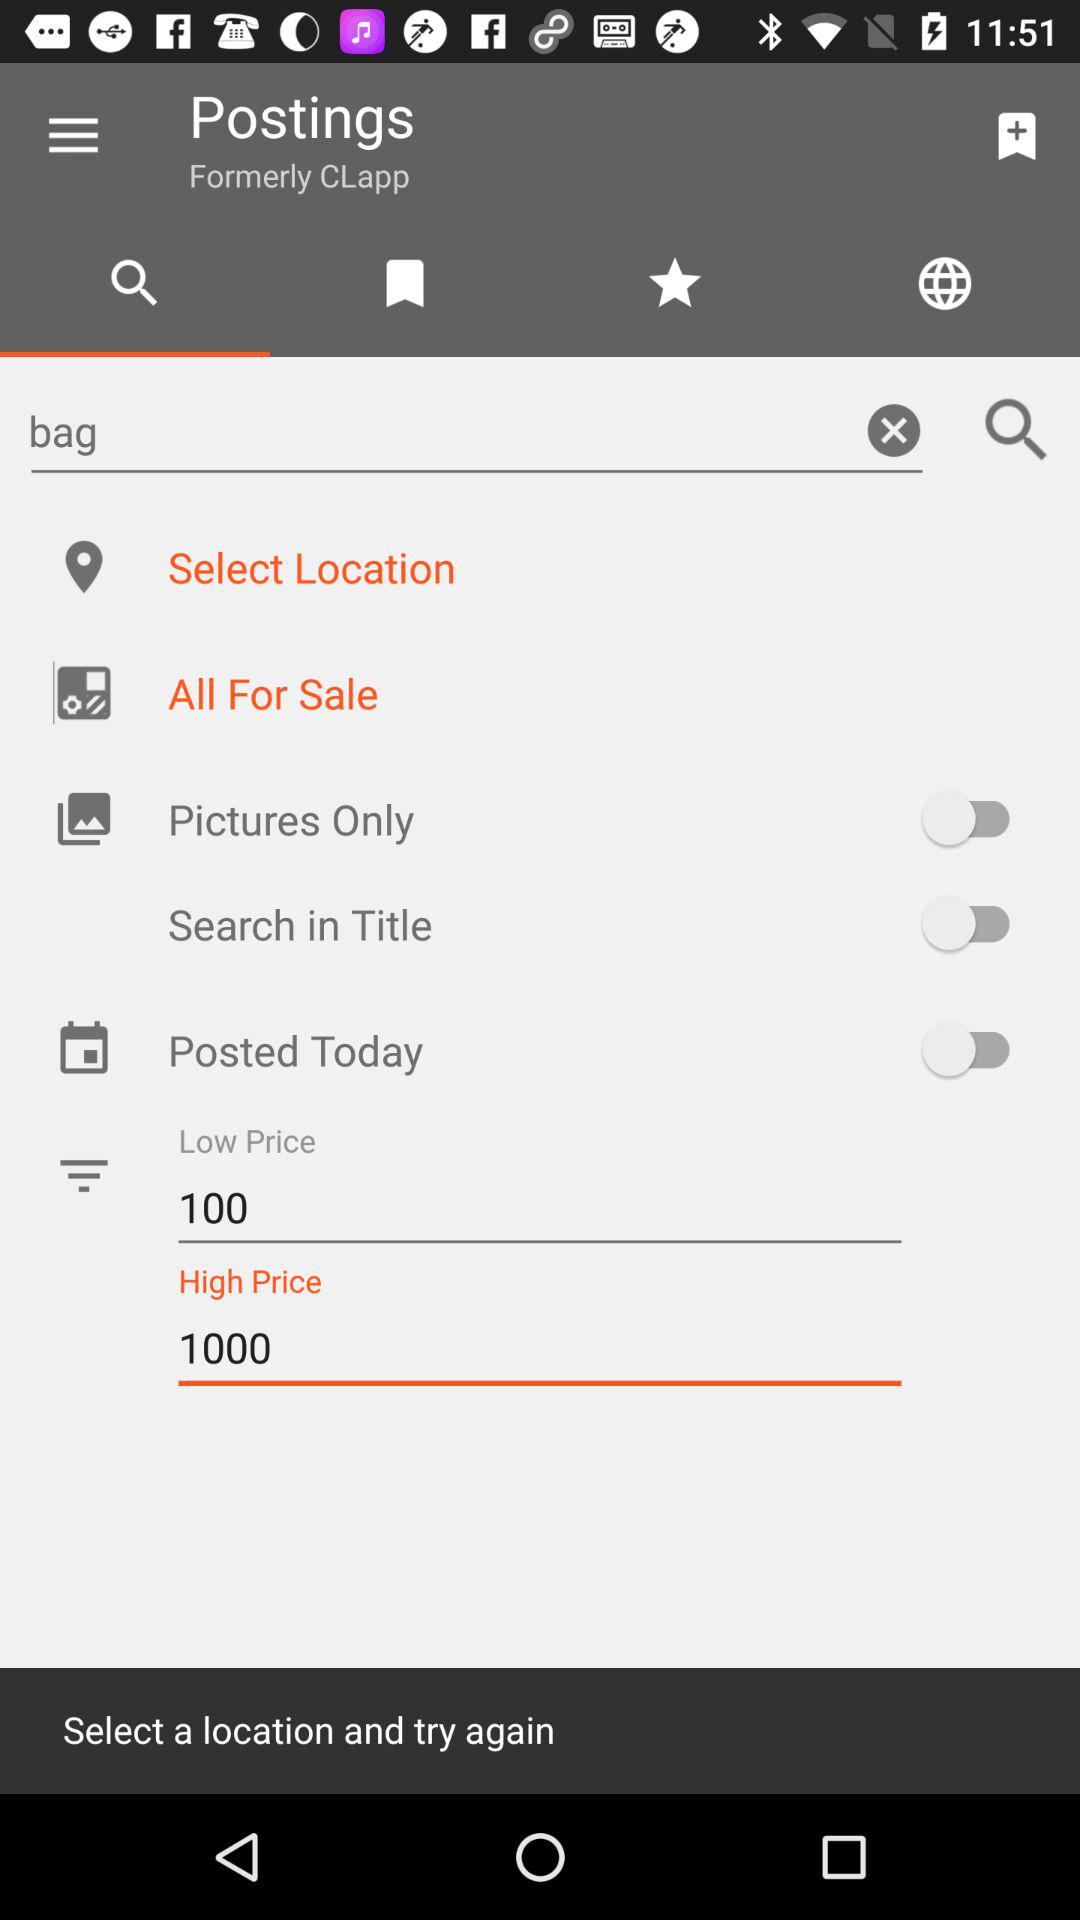How many price options are available?
Answer the question using a single word or phrase. 2 